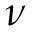<formula> <loc_0><loc_0><loc_500><loc_500>\nu</formula> 